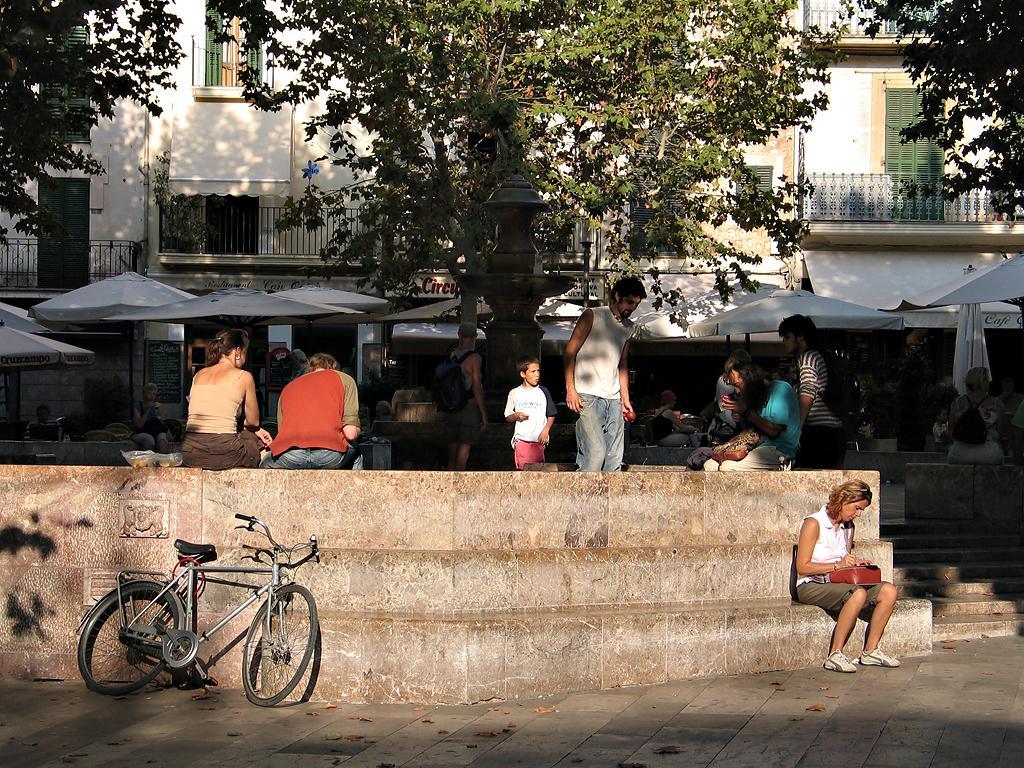In one or two sentences, can you explain what this image depicts? In this image on the left side I can see a bicycle. I can see some people. In the background, I can see the trees and the buildings. 